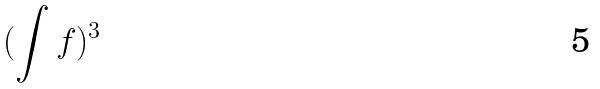Convert formula to latex. <formula><loc_0><loc_0><loc_500><loc_500>( \int f ) ^ { 3 }</formula> 